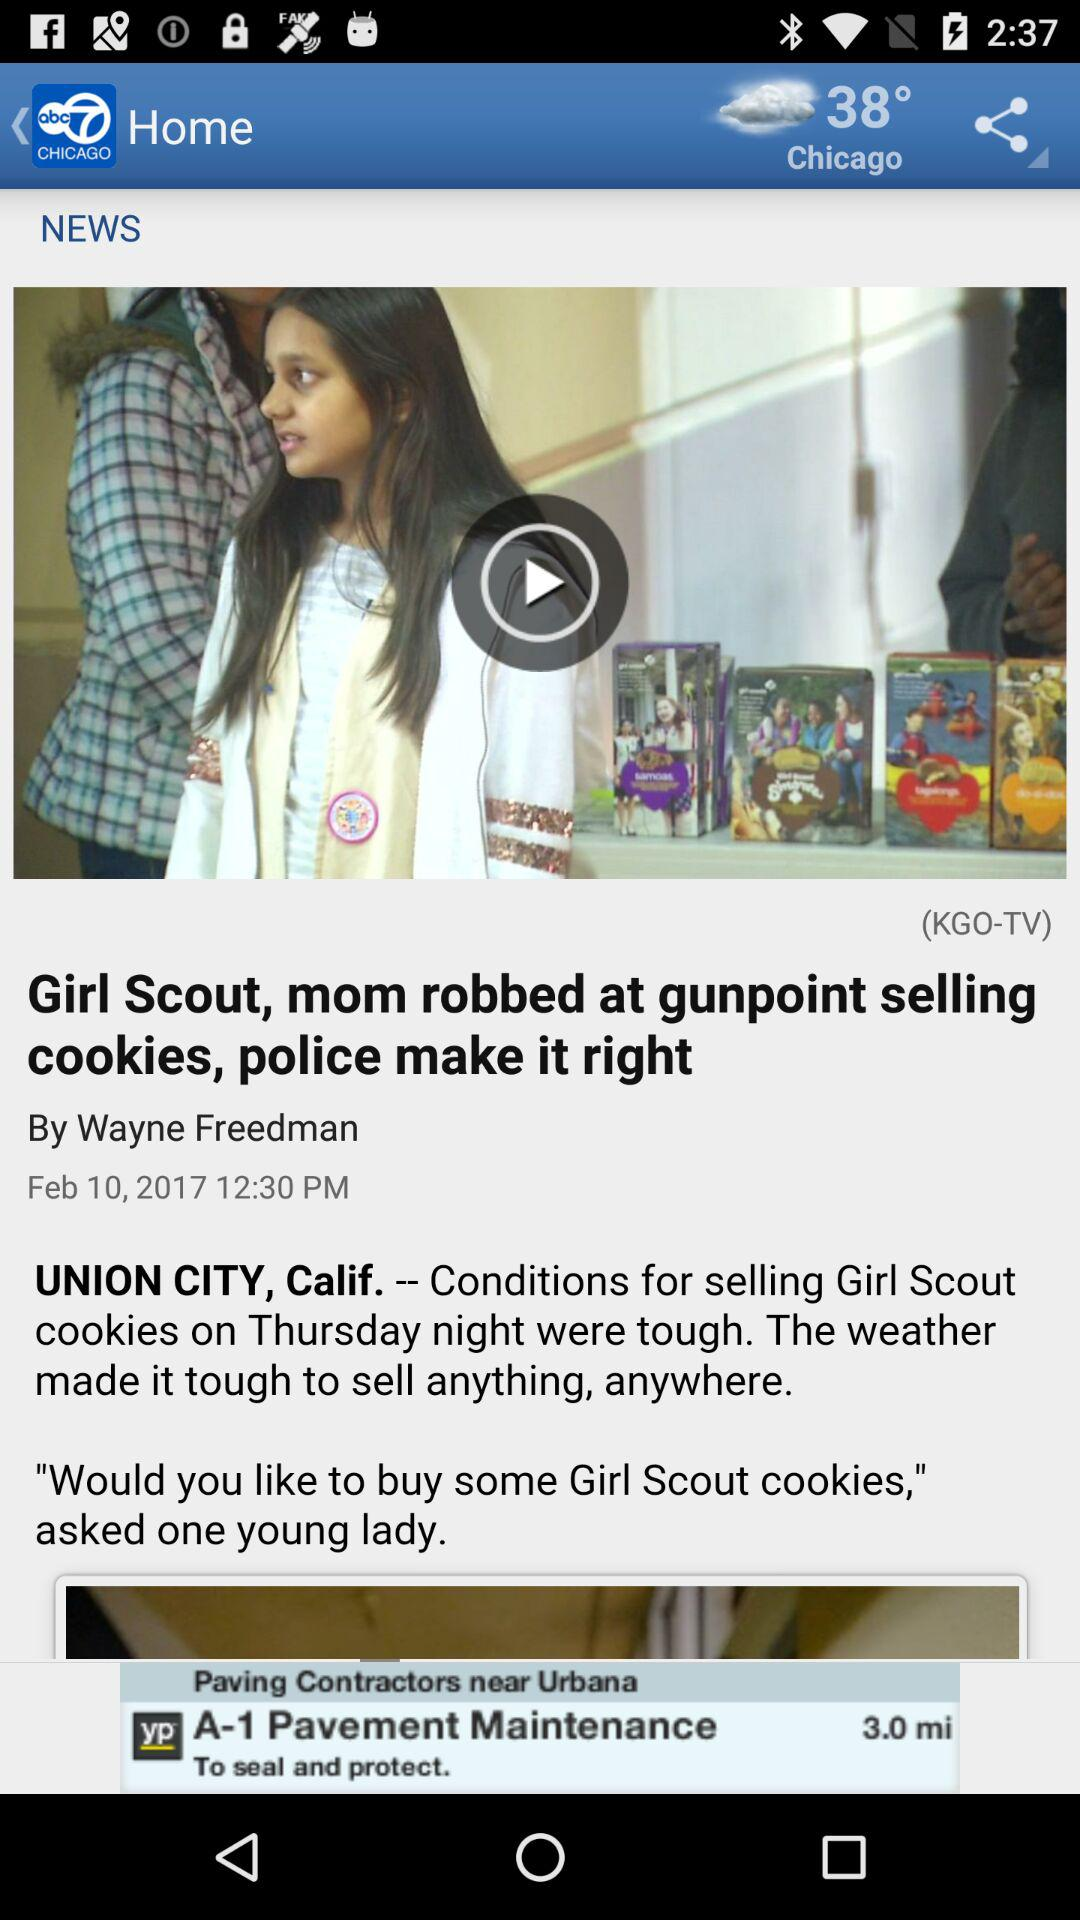How many degrees is the temperature in Chicago?
Answer the question using a single word or phrase. 38° 